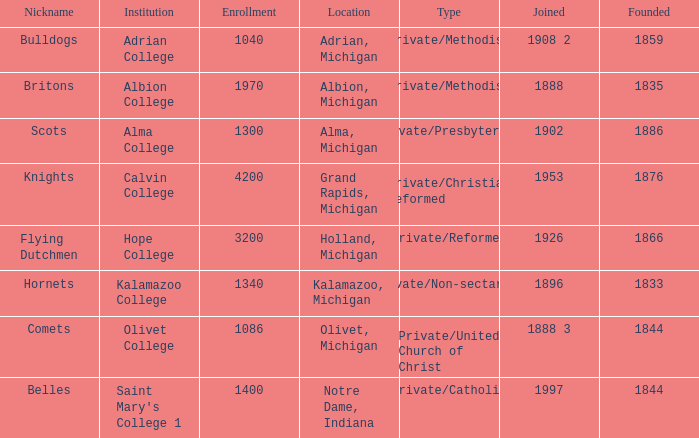How many categories fall under the category of britons? 1.0. 